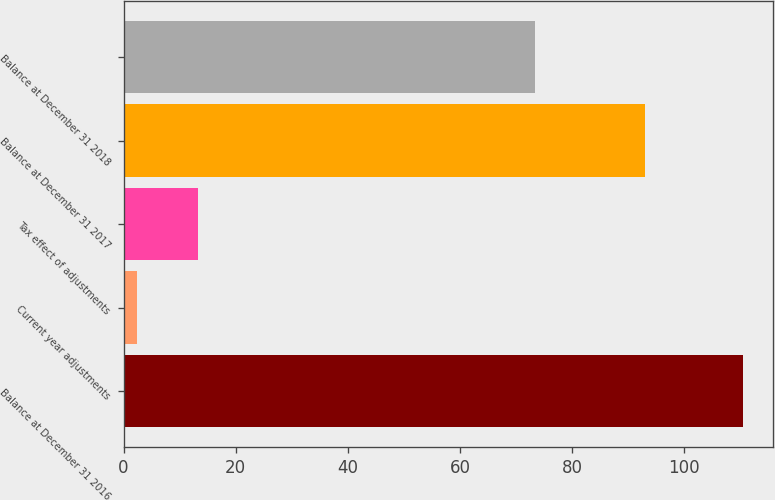<chart> <loc_0><loc_0><loc_500><loc_500><bar_chart><fcel>Balance at December 31 2016<fcel>Current year adjustments<fcel>Tax effect of adjustments<fcel>Balance at December 31 2017<fcel>Balance at December 31 2018<nl><fcel>110.4<fcel>2.4<fcel>13.2<fcel>93<fcel>73.3<nl></chart> 